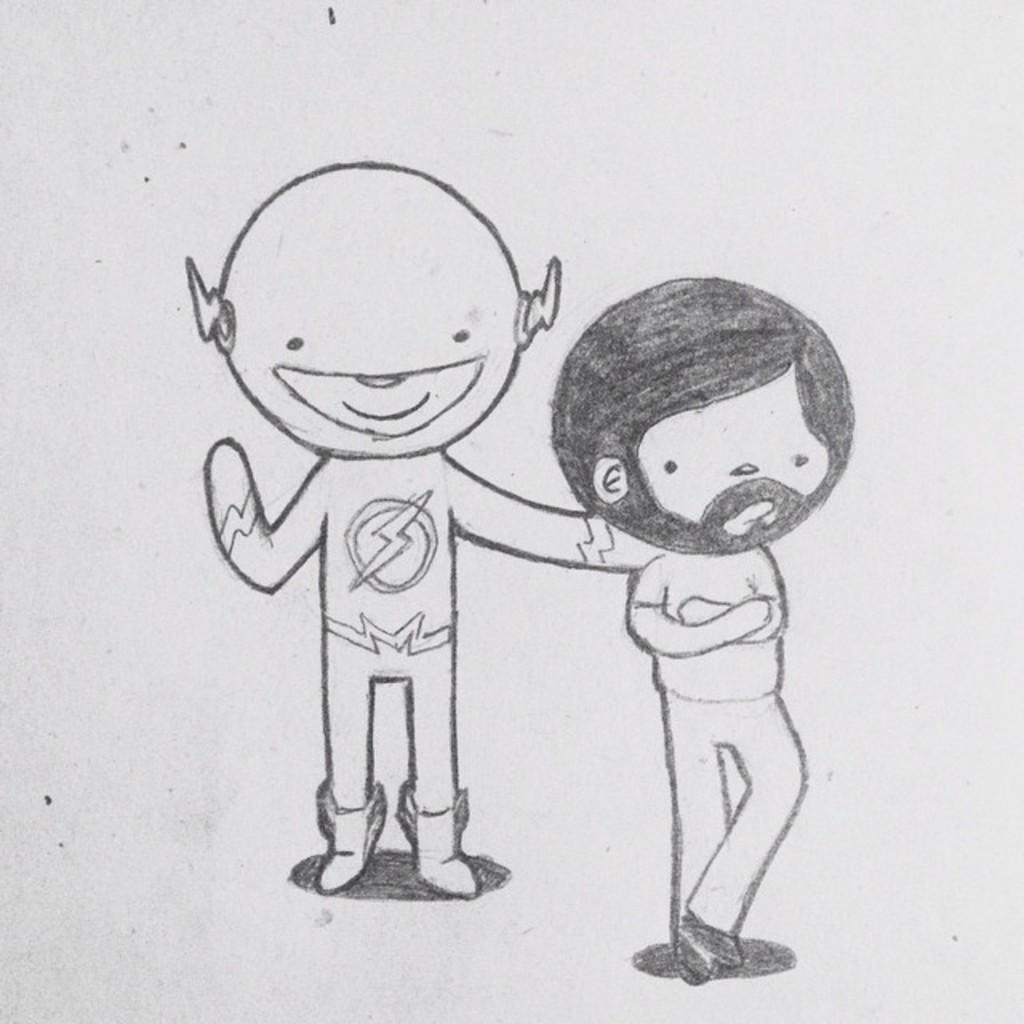What is the main subject of the drawing in the image? The drawing depicts a man and a robot. What color is the paper on which the drawing is made? The paper is white. What is the primary purpose of the drawing? The drawing contains a depiction of a man and a robot. How many icicles are hanging from the man's hat in the drawing? There are no icicles present in the drawing; it depicts a man and a robot. What type of treatment is being administered to the robot in the drawing? There is no treatment being administered to the robot in the drawing; it is simply depicted alongside the man. 